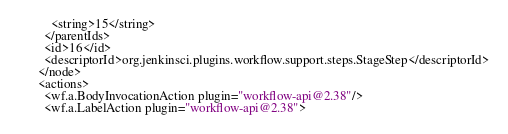Convert code to text. <code><loc_0><loc_0><loc_500><loc_500><_XML_>      <string>15</string>
    </parentIds>
    <id>16</id>
    <descriptorId>org.jenkinsci.plugins.workflow.support.steps.StageStep</descriptorId>
  </node>
  <actions>
    <wf.a.BodyInvocationAction plugin="workflow-api@2.38"/>
    <wf.a.LabelAction plugin="workflow-api@2.38"></code> 